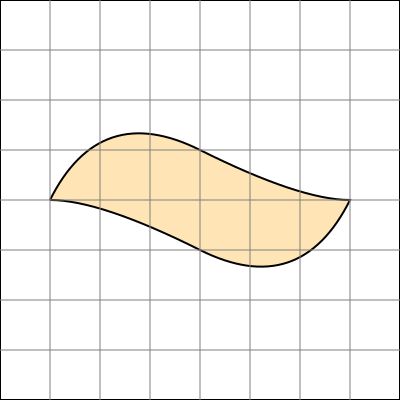The retired baker has made a special pancake for you! To figure out how much syrup you'll need, you want to calculate the area of this irregularly shaped pancake. If each square in the grid represents 1 square inch, what is the approximate area of the pancake in square inches? To find the approximate area of the irregularly shaped pancake, we'll use the counting squares method:

1. Count the number of full squares inside the pancake shape.
2. Estimate partial squares as either half squares or quarter squares.
3. Add up all the counted squares.

Let's break it down:

1. Full squares: There are approximately 30 full squares within the pancake shape.

2. Partial squares:
   - There are about 20 half squares (0.5 each) around the edges.
   - There are roughly 8 quarter squares (0.25 each) at the corners.

3. Calculation:
   $$ \text{Area} = \text{Full squares} + \text{Half squares} + \text{Quarter squares} $$
   $$ = 30 + (20 \times 0.5) + (8 \times 0.25) $$
   $$ = 30 + 10 + 2 $$
   $$ = 42 \text{ square inches} $$

Therefore, the approximate area of the pancake is 42 square inches.
Answer: 42 square inches 